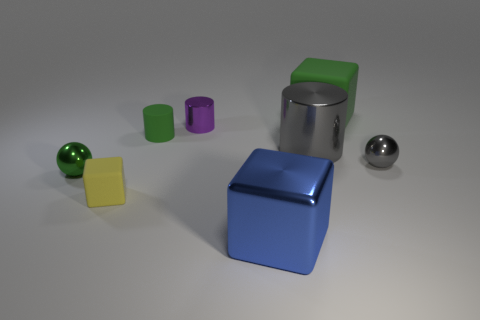Are there any green metallic objects on the right side of the small shiny sphere to the right of the small shiny ball to the left of the small rubber cylinder?
Offer a terse response. No. There is a big thing in front of the tiny yellow cube; what is it made of?
Ensure brevity in your answer.  Metal. How many large objects are green matte objects or cyan spheres?
Provide a succinct answer. 1. There is a metallic ball to the right of the green block; is its size the same as the yellow thing?
Give a very brief answer. Yes. What number of other objects are there of the same color as the large cylinder?
Ensure brevity in your answer.  1. What material is the gray ball?
Your response must be concise. Metal. There is a big object that is in front of the tiny green cylinder and behind the small yellow block; what material is it?
Ensure brevity in your answer.  Metal. What number of objects are either blocks behind the small green cylinder or shiny balls?
Your response must be concise. 3. Does the big rubber block have the same color as the matte cylinder?
Give a very brief answer. Yes. Are there any balls of the same size as the yellow rubber cube?
Your answer should be compact. Yes. 